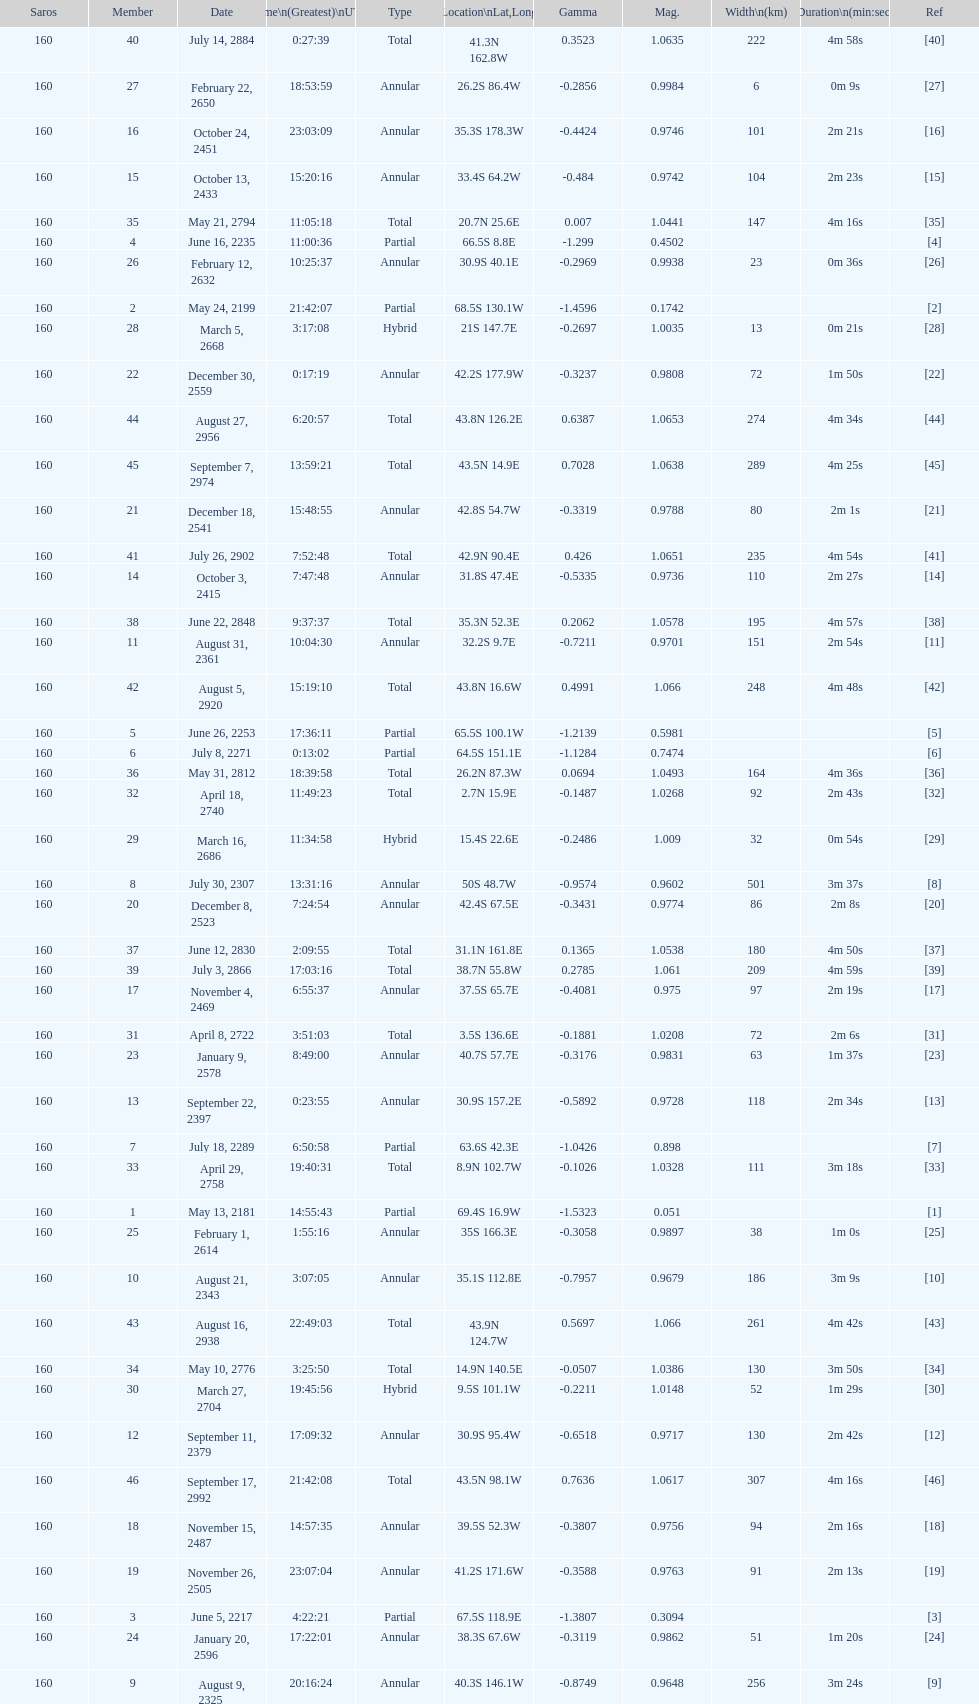Which one has a larger width, 8 or 21? 8. 